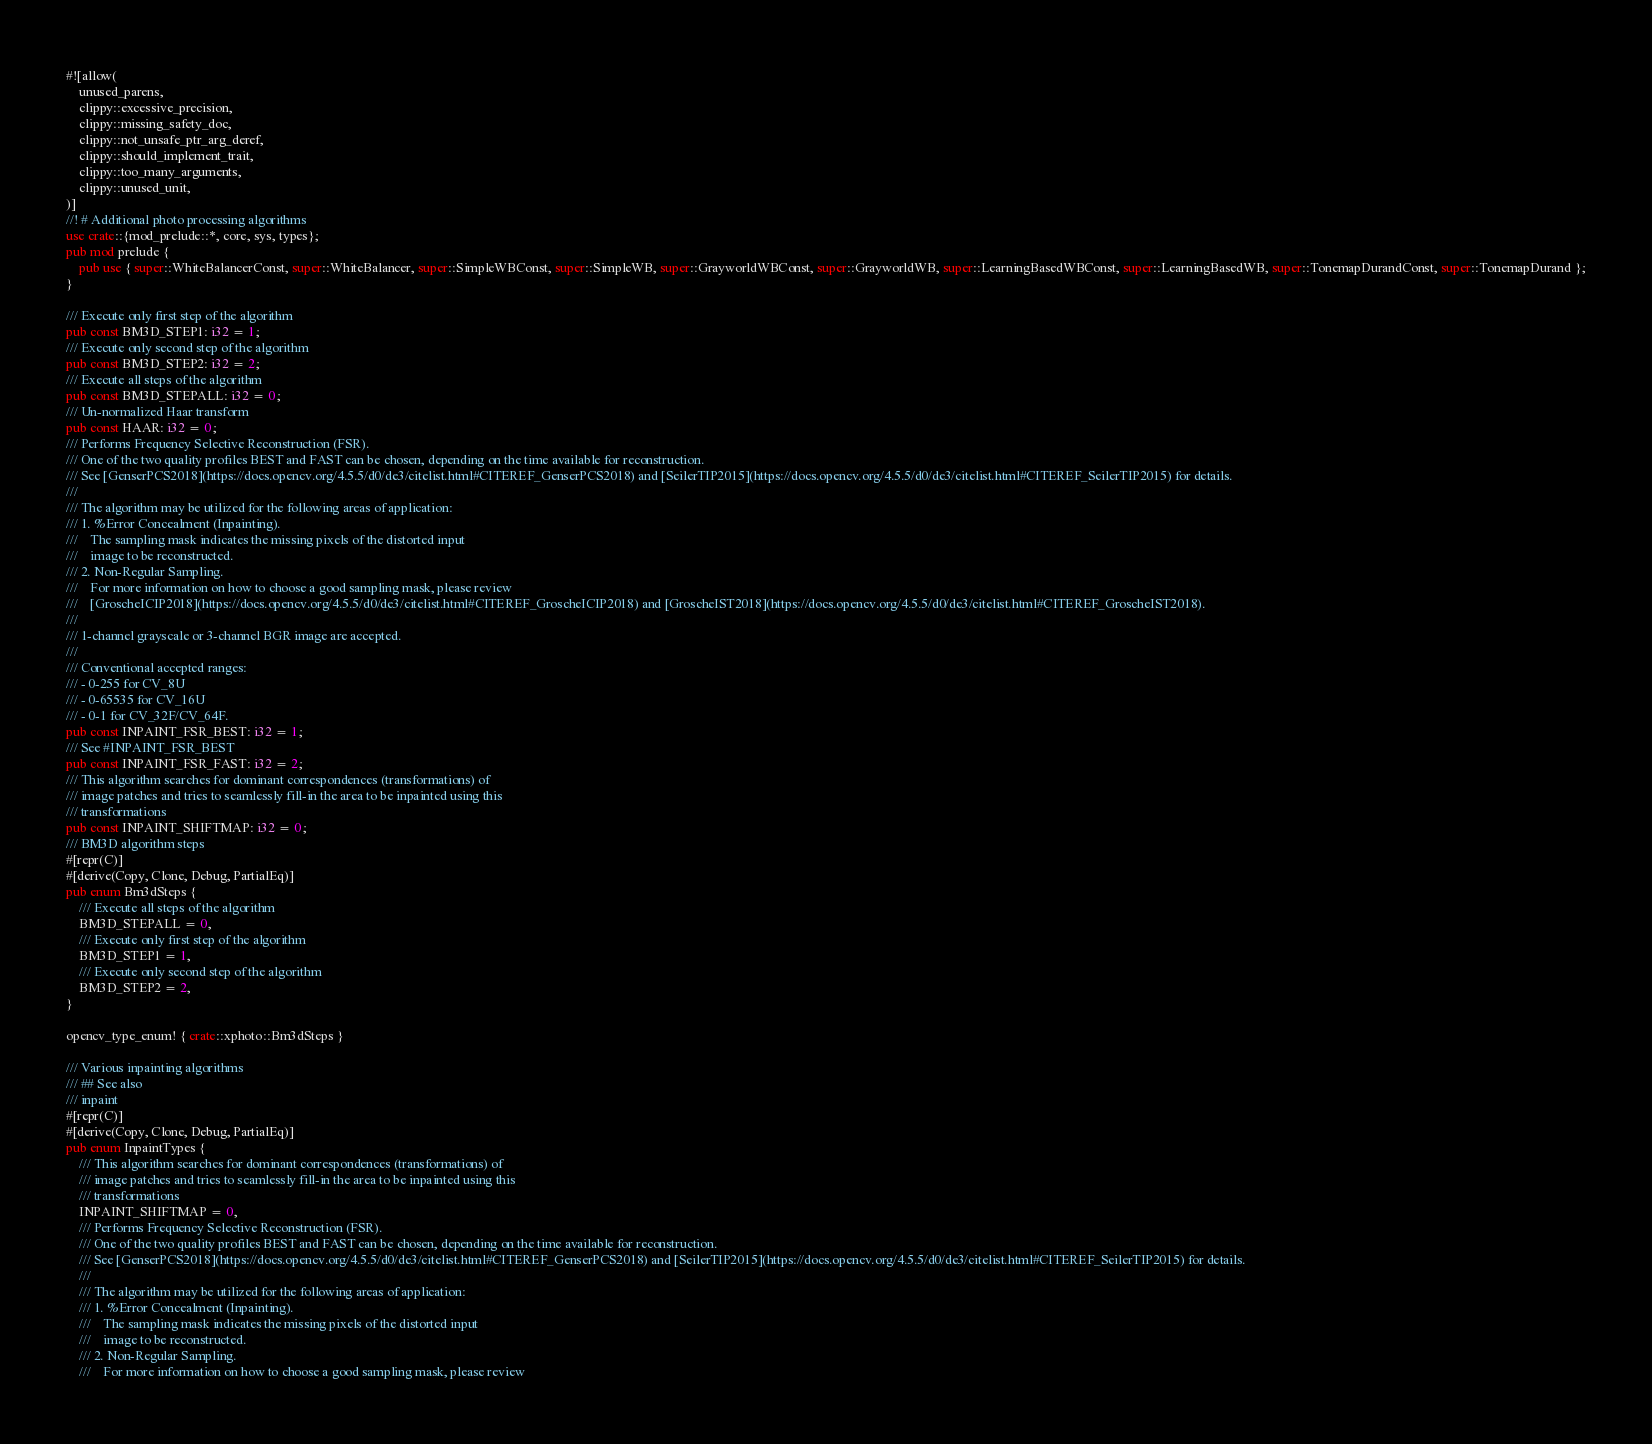<code> <loc_0><loc_0><loc_500><loc_500><_Rust_>#![allow(
	unused_parens,
	clippy::excessive_precision,
	clippy::missing_safety_doc,
	clippy::not_unsafe_ptr_arg_deref,
	clippy::should_implement_trait,
	clippy::too_many_arguments,
	clippy::unused_unit,
)]
//! # Additional photo processing algorithms
use crate::{mod_prelude::*, core, sys, types};
pub mod prelude {
	pub use { super::WhiteBalancerConst, super::WhiteBalancer, super::SimpleWBConst, super::SimpleWB, super::GrayworldWBConst, super::GrayworldWB, super::LearningBasedWBConst, super::LearningBasedWB, super::TonemapDurandConst, super::TonemapDurand };
}

/// Execute only first step of the algorithm
pub const BM3D_STEP1: i32 = 1;
/// Execute only second step of the algorithm
pub const BM3D_STEP2: i32 = 2;
/// Execute all steps of the algorithm
pub const BM3D_STEPALL: i32 = 0;
/// Un-normalized Haar transform
pub const HAAR: i32 = 0;
/// Performs Frequency Selective Reconstruction (FSR).
/// One of the two quality profiles BEST and FAST can be chosen, depending on the time available for reconstruction.
/// See [GenserPCS2018](https://docs.opencv.org/4.5.5/d0/de3/citelist.html#CITEREF_GenserPCS2018) and [SeilerTIP2015](https://docs.opencv.org/4.5.5/d0/de3/citelist.html#CITEREF_SeilerTIP2015) for details.
/// 
/// The algorithm may be utilized for the following areas of application:
/// 1. %Error Concealment (Inpainting).
///    The sampling mask indicates the missing pixels of the distorted input
///    image to be reconstructed.
/// 2. Non-Regular Sampling.
///    For more information on how to choose a good sampling mask, please review
///    [GroscheICIP2018](https://docs.opencv.org/4.5.5/d0/de3/citelist.html#CITEREF_GroscheICIP2018) and [GroscheIST2018](https://docs.opencv.org/4.5.5/d0/de3/citelist.html#CITEREF_GroscheIST2018).
/// 
/// 1-channel grayscale or 3-channel BGR image are accepted.
/// 
/// Conventional accepted ranges:
/// - 0-255 for CV_8U
/// - 0-65535 for CV_16U
/// - 0-1 for CV_32F/CV_64F.
pub const INPAINT_FSR_BEST: i32 = 1;
/// See #INPAINT_FSR_BEST
pub const INPAINT_FSR_FAST: i32 = 2;
/// This algorithm searches for dominant correspondences (transformations) of
/// image patches and tries to seamlessly fill-in the area to be inpainted using this
/// transformations
pub const INPAINT_SHIFTMAP: i32 = 0;
/// BM3D algorithm steps
#[repr(C)]
#[derive(Copy, Clone, Debug, PartialEq)]
pub enum Bm3dSteps {
	/// Execute all steps of the algorithm
	BM3D_STEPALL = 0,
	/// Execute only first step of the algorithm
	BM3D_STEP1 = 1,
	/// Execute only second step of the algorithm
	BM3D_STEP2 = 2,
}

opencv_type_enum! { crate::xphoto::Bm3dSteps }

/// Various inpainting algorithms
/// ## See also
/// inpaint
#[repr(C)]
#[derive(Copy, Clone, Debug, PartialEq)]
pub enum InpaintTypes {
	/// This algorithm searches for dominant correspondences (transformations) of
	/// image patches and tries to seamlessly fill-in the area to be inpainted using this
	/// transformations
	INPAINT_SHIFTMAP = 0,
	/// Performs Frequency Selective Reconstruction (FSR).
	/// One of the two quality profiles BEST and FAST can be chosen, depending on the time available for reconstruction.
	/// See [GenserPCS2018](https://docs.opencv.org/4.5.5/d0/de3/citelist.html#CITEREF_GenserPCS2018) and [SeilerTIP2015](https://docs.opencv.org/4.5.5/d0/de3/citelist.html#CITEREF_SeilerTIP2015) for details.
	/// 
	/// The algorithm may be utilized for the following areas of application:
	/// 1. %Error Concealment (Inpainting).
	///    The sampling mask indicates the missing pixels of the distorted input
	///    image to be reconstructed.
	/// 2. Non-Regular Sampling.
	///    For more information on how to choose a good sampling mask, please review</code> 